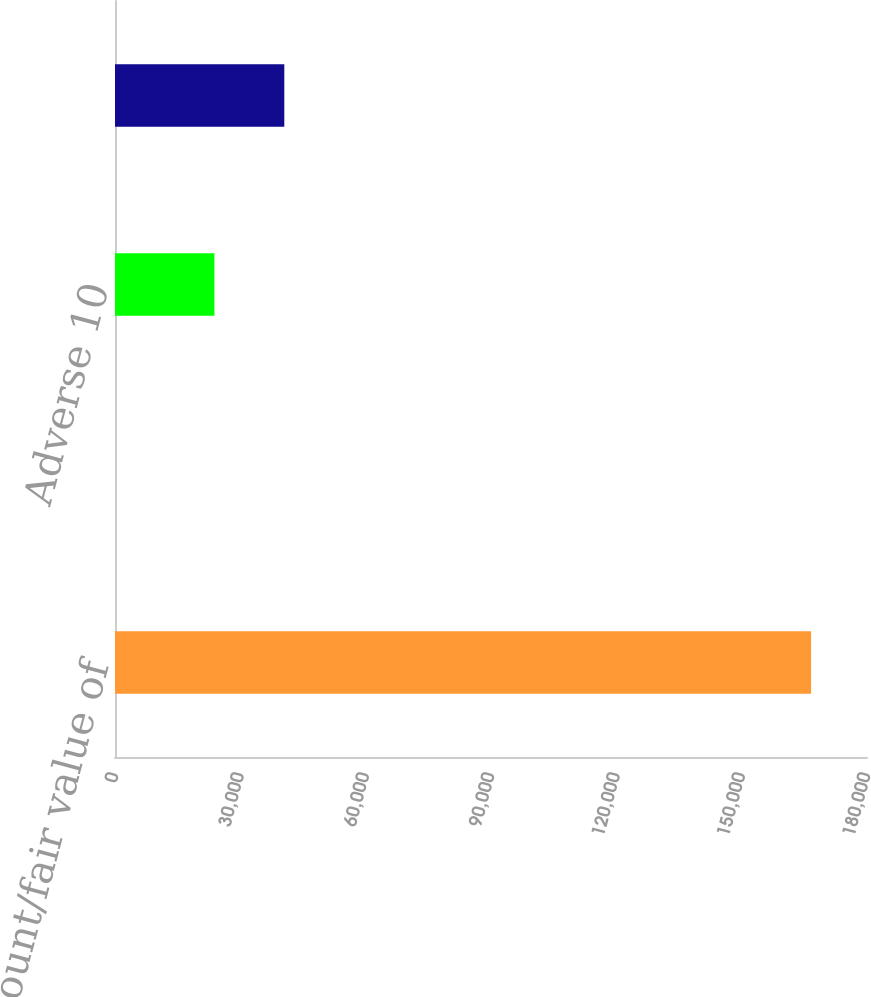Convert chart to OTSL. <chart><loc_0><loc_0><loc_500><loc_500><bar_chart><fcel>Carrying amount/fair value of<fcel>Weighted average life (in<fcel>Adverse 10<fcel>Adverse 20<nl><fcel>166614<fcel>1.2<fcel>23801<fcel>40525<nl></chart> 